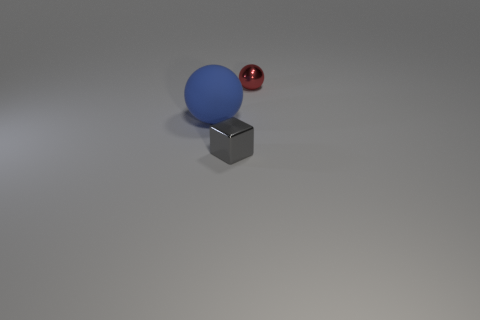Subtract all cubes. How many objects are left? 2 Add 3 big brown matte balls. How many objects exist? 6 Subtract 1 cubes. How many cubes are left? 0 Subtract 0 brown cubes. How many objects are left? 3 Subtract all gray balls. Subtract all red cylinders. How many balls are left? 2 Subtract all tiny red things. Subtract all blue rubber spheres. How many objects are left? 1 Add 3 gray metal objects. How many gray metal objects are left? 4 Add 1 metallic cubes. How many metallic cubes exist? 2 